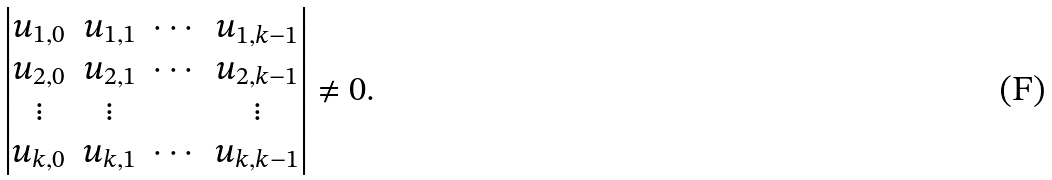Convert formula to latex. <formula><loc_0><loc_0><loc_500><loc_500>\begin{vmatrix} u _ { 1 , 0 } & u _ { 1 , 1 } & \cdots & u _ { 1 , k - 1 } \\ u _ { 2 , 0 } & u _ { 2 , 1 } & \cdots & u _ { 2 , k - 1 } \\ \vdots & \vdots & & \vdots \\ u _ { k , 0 } & u _ { k , 1 } & \cdots & u _ { k , k - 1 } \end{vmatrix} \neq 0 .</formula> 